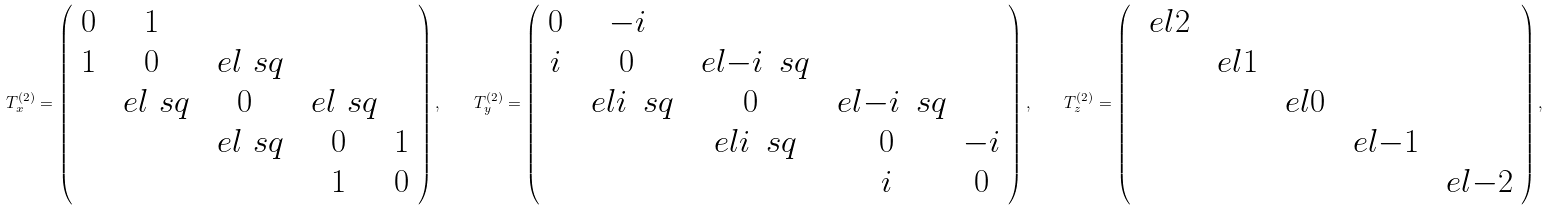<formula> <loc_0><loc_0><loc_500><loc_500>T _ { x } ^ { ( 2 ) } = \left ( \begin{array} { c c c c c } 0 & 1 \\ 1 & 0 & \ e l { \ s q } \\ & \ e l { \ s q } & 0 & \ e l { \ s q } \\ & & \ e l { \ s q } & 0 & 1 \\ & & & 1 & 0 \end{array} \right ) , \quad T _ { y } ^ { ( 2 ) } = \left ( \begin{array} { c c c c c } 0 & - i \\ i & 0 & \ e l { - i \, \ s q } \\ & \ e l { i \, \ s q } & 0 & \ e l { - i \, \ s q } \\ & & \ e l { i \, \ s q } & 0 & - i \\ & & & i & 0 \end{array} \right ) , \quad T _ { z } ^ { ( 2 ) } = \left ( \begin{array} { c c c c c } \ e l 2 \\ & \ e l 1 \\ & & \ e l 0 \\ & & & \ e l { - 1 } \\ & & & & \ e l { - 2 } \end{array} \right ) ,</formula> 